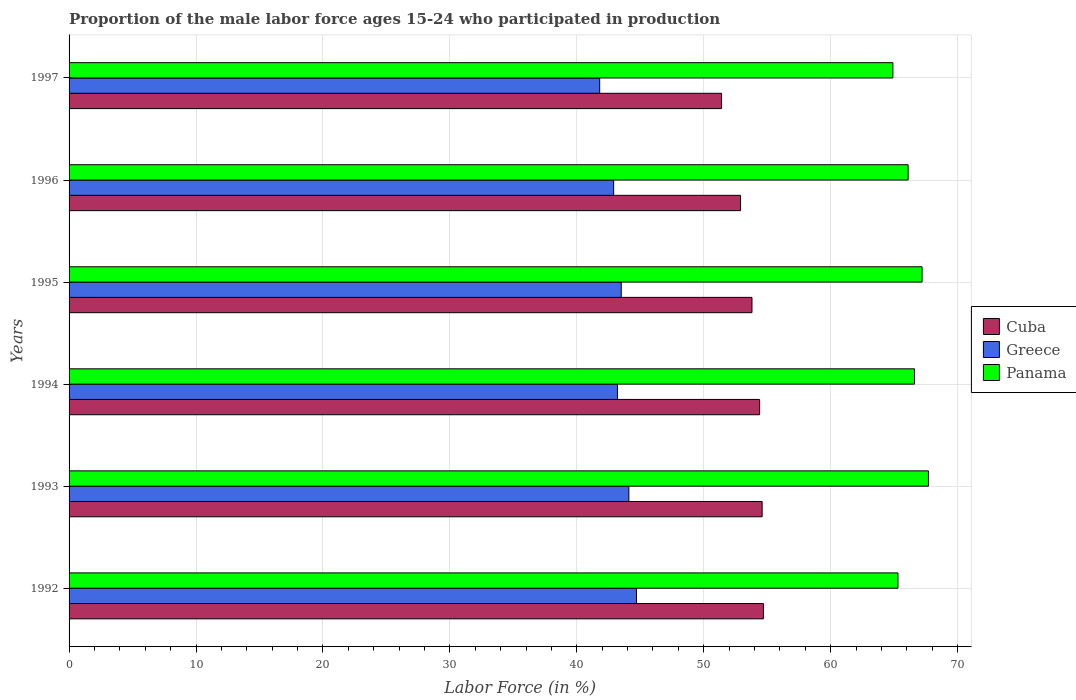What is the proportion of the male labor force who participated in production in Panama in 1996?
Keep it short and to the point. 66.1. Across all years, what is the maximum proportion of the male labor force who participated in production in Greece?
Offer a terse response. 44.7. Across all years, what is the minimum proportion of the male labor force who participated in production in Cuba?
Provide a short and direct response. 51.4. In which year was the proportion of the male labor force who participated in production in Cuba maximum?
Provide a short and direct response. 1992. In which year was the proportion of the male labor force who participated in production in Cuba minimum?
Your answer should be compact. 1997. What is the total proportion of the male labor force who participated in production in Cuba in the graph?
Keep it short and to the point. 321.8. What is the difference between the proportion of the male labor force who participated in production in Panama in 1994 and that in 1995?
Provide a short and direct response. -0.6. What is the difference between the proportion of the male labor force who participated in production in Greece in 1994 and the proportion of the male labor force who participated in production in Panama in 1996?
Keep it short and to the point. -22.9. What is the average proportion of the male labor force who participated in production in Greece per year?
Provide a succinct answer. 43.37. In the year 1994, what is the difference between the proportion of the male labor force who participated in production in Cuba and proportion of the male labor force who participated in production in Greece?
Give a very brief answer. 11.2. In how many years, is the proportion of the male labor force who participated in production in Panama greater than 58 %?
Offer a terse response. 6. What is the ratio of the proportion of the male labor force who participated in production in Panama in 1994 to that in 1997?
Your answer should be very brief. 1.03. Is the proportion of the male labor force who participated in production in Greece in 1992 less than that in 1997?
Your answer should be very brief. No. Is the difference between the proportion of the male labor force who participated in production in Cuba in 1993 and 1994 greater than the difference between the proportion of the male labor force who participated in production in Greece in 1993 and 1994?
Keep it short and to the point. No. What is the difference between the highest and the second highest proportion of the male labor force who participated in production in Cuba?
Give a very brief answer. 0.1. What is the difference between the highest and the lowest proportion of the male labor force who participated in production in Panama?
Ensure brevity in your answer.  2.8. Is the sum of the proportion of the male labor force who participated in production in Greece in 1993 and 1997 greater than the maximum proportion of the male labor force who participated in production in Cuba across all years?
Keep it short and to the point. Yes. What does the 1st bar from the top in 1994 represents?
Ensure brevity in your answer.  Panama. What does the 3rd bar from the bottom in 1993 represents?
Make the answer very short. Panama. Are all the bars in the graph horizontal?
Keep it short and to the point. Yes. Are the values on the major ticks of X-axis written in scientific E-notation?
Provide a succinct answer. No. Does the graph contain any zero values?
Offer a very short reply. No. Does the graph contain grids?
Give a very brief answer. Yes. How many legend labels are there?
Offer a very short reply. 3. How are the legend labels stacked?
Your response must be concise. Vertical. What is the title of the graph?
Offer a very short reply. Proportion of the male labor force ages 15-24 who participated in production. Does "Sao Tome and Principe" appear as one of the legend labels in the graph?
Provide a short and direct response. No. What is the label or title of the X-axis?
Ensure brevity in your answer.  Labor Force (in %). What is the label or title of the Y-axis?
Make the answer very short. Years. What is the Labor Force (in %) in Cuba in 1992?
Offer a very short reply. 54.7. What is the Labor Force (in %) of Greece in 1992?
Ensure brevity in your answer.  44.7. What is the Labor Force (in %) in Panama in 1992?
Your response must be concise. 65.3. What is the Labor Force (in %) in Cuba in 1993?
Your response must be concise. 54.6. What is the Labor Force (in %) of Greece in 1993?
Give a very brief answer. 44.1. What is the Labor Force (in %) of Panama in 1993?
Provide a short and direct response. 67.7. What is the Labor Force (in %) in Cuba in 1994?
Provide a short and direct response. 54.4. What is the Labor Force (in %) in Greece in 1994?
Offer a very short reply. 43.2. What is the Labor Force (in %) in Panama in 1994?
Provide a short and direct response. 66.6. What is the Labor Force (in %) of Cuba in 1995?
Give a very brief answer. 53.8. What is the Labor Force (in %) of Greece in 1995?
Ensure brevity in your answer.  43.5. What is the Labor Force (in %) in Panama in 1995?
Offer a terse response. 67.2. What is the Labor Force (in %) of Cuba in 1996?
Your answer should be very brief. 52.9. What is the Labor Force (in %) of Greece in 1996?
Make the answer very short. 42.9. What is the Labor Force (in %) in Panama in 1996?
Your response must be concise. 66.1. What is the Labor Force (in %) in Cuba in 1997?
Offer a very short reply. 51.4. What is the Labor Force (in %) in Greece in 1997?
Offer a very short reply. 41.8. What is the Labor Force (in %) in Panama in 1997?
Keep it short and to the point. 64.9. Across all years, what is the maximum Labor Force (in %) of Cuba?
Your answer should be compact. 54.7. Across all years, what is the maximum Labor Force (in %) of Greece?
Your answer should be compact. 44.7. Across all years, what is the maximum Labor Force (in %) in Panama?
Provide a short and direct response. 67.7. Across all years, what is the minimum Labor Force (in %) in Cuba?
Provide a short and direct response. 51.4. Across all years, what is the minimum Labor Force (in %) of Greece?
Your response must be concise. 41.8. Across all years, what is the minimum Labor Force (in %) in Panama?
Make the answer very short. 64.9. What is the total Labor Force (in %) in Cuba in the graph?
Provide a short and direct response. 321.8. What is the total Labor Force (in %) in Greece in the graph?
Your answer should be compact. 260.2. What is the total Labor Force (in %) in Panama in the graph?
Make the answer very short. 397.8. What is the difference between the Labor Force (in %) of Cuba in 1992 and that in 1993?
Ensure brevity in your answer.  0.1. What is the difference between the Labor Force (in %) of Panama in 1992 and that in 1993?
Make the answer very short. -2.4. What is the difference between the Labor Force (in %) in Cuba in 1992 and that in 1994?
Give a very brief answer. 0.3. What is the difference between the Labor Force (in %) of Greece in 1992 and that in 1994?
Offer a terse response. 1.5. What is the difference between the Labor Force (in %) in Panama in 1992 and that in 1994?
Your response must be concise. -1.3. What is the difference between the Labor Force (in %) of Greece in 1992 and that in 1995?
Keep it short and to the point. 1.2. What is the difference between the Labor Force (in %) of Greece in 1992 and that in 1996?
Your answer should be very brief. 1.8. What is the difference between the Labor Force (in %) of Panama in 1992 and that in 1996?
Your answer should be compact. -0.8. What is the difference between the Labor Force (in %) in Cuba in 1992 and that in 1997?
Your answer should be compact. 3.3. What is the difference between the Labor Force (in %) of Greece in 1992 and that in 1997?
Your response must be concise. 2.9. What is the difference between the Labor Force (in %) in Panama in 1992 and that in 1997?
Offer a very short reply. 0.4. What is the difference between the Labor Force (in %) in Cuba in 1993 and that in 1994?
Offer a very short reply. 0.2. What is the difference between the Labor Force (in %) of Greece in 1993 and that in 1995?
Provide a short and direct response. 0.6. What is the difference between the Labor Force (in %) of Panama in 1993 and that in 1995?
Keep it short and to the point. 0.5. What is the difference between the Labor Force (in %) in Greece in 1993 and that in 1996?
Ensure brevity in your answer.  1.2. What is the difference between the Labor Force (in %) of Panama in 1993 and that in 1996?
Keep it short and to the point. 1.6. What is the difference between the Labor Force (in %) in Cuba in 1993 and that in 1997?
Your answer should be very brief. 3.2. What is the difference between the Labor Force (in %) of Greece in 1993 and that in 1997?
Your answer should be compact. 2.3. What is the difference between the Labor Force (in %) in Panama in 1993 and that in 1997?
Keep it short and to the point. 2.8. What is the difference between the Labor Force (in %) of Cuba in 1994 and that in 1995?
Provide a short and direct response. 0.6. What is the difference between the Labor Force (in %) in Greece in 1994 and that in 1995?
Provide a short and direct response. -0.3. What is the difference between the Labor Force (in %) of Panama in 1994 and that in 1995?
Make the answer very short. -0.6. What is the difference between the Labor Force (in %) of Greece in 1994 and that in 1996?
Provide a short and direct response. 0.3. What is the difference between the Labor Force (in %) of Panama in 1994 and that in 1996?
Ensure brevity in your answer.  0.5. What is the difference between the Labor Force (in %) of Cuba in 1994 and that in 1997?
Your answer should be compact. 3. What is the difference between the Labor Force (in %) of Greece in 1995 and that in 1996?
Your answer should be very brief. 0.6. What is the difference between the Labor Force (in %) of Cuba in 1995 and that in 1997?
Your response must be concise. 2.4. What is the difference between the Labor Force (in %) of Greece in 1996 and that in 1997?
Offer a very short reply. 1.1. What is the difference between the Labor Force (in %) of Cuba in 1992 and the Labor Force (in %) of Greece in 1994?
Your answer should be compact. 11.5. What is the difference between the Labor Force (in %) in Greece in 1992 and the Labor Force (in %) in Panama in 1994?
Provide a short and direct response. -21.9. What is the difference between the Labor Force (in %) in Cuba in 1992 and the Labor Force (in %) in Greece in 1995?
Provide a short and direct response. 11.2. What is the difference between the Labor Force (in %) of Greece in 1992 and the Labor Force (in %) of Panama in 1995?
Provide a succinct answer. -22.5. What is the difference between the Labor Force (in %) of Cuba in 1992 and the Labor Force (in %) of Panama in 1996?
Give a very brief answer. -11.4. What is the difference between the Labor Force (in %) in Greece in 1992 and the Labor Force (in %) in Panama in 1996?
Make the answer very short. -21.4. What is the difference between the Labor Force (in %) in Cuba in 1992 and the Labor Force (in %) in Panama in 1997?
Provide a succinct answer. -10.2. What is the difference between the Labor Force (in %) of Greece in 1992 and the Labor Force (in %) of Panama in 1997?
Offer a terse response. -20.2. What is the difference between the Labor Force (in %) of Cuba in 1993 and the Labor Force (in %) of Greece in 1994?
Ensure brevity in your answer.  11.4. What is the difference between the Labor Force (in %) of Greece in 1993 and the Labor Force (in %) of Panama in 1994?
Give a very brief answer. -22.5. What is the difference between the Labor Force (in %) in Cuba in 1993 and the Labor Force (in %) in Panama in 1995?
Make the answer very short. -12.6. What is the difference between the Labor Force (in %) of Greece in 1993 and the Labor Force (in %) of Panama in 1995?
Offer a very short reply. -23.1. What is the difference between the Labor Force (in %) of Cuba in 1993 and the Labor Force (in %) of Panama in 1996?
Provide a succinct answer. -11.5. What is the difference between the Labor Force (in %) in Greece in 1993 and the Labor Force (in %) in Panama in 1996?
Make the answer very short. -22. What is the difference between the Labor Force (in %) in Greece in 1993 and the Labor Force (in %) in Panama in 1997?
Your answer should be compact. -20.8. What is the difference between the Labor Force (in %) of Cuba in 1994 and the Labor Force (in %) of Panama in 1995?
Your answer should be compact. -12.8. What is the difference between the Labor Force (in %) in Cuba in 1994 and the Labor Force (in %) in Greece in 1996?
Provide a short and direct response. 11.5. What is the difference between the Labor Force (in %) in Cuba in 1994 and the Labor Force (in %) in Panama in 1996?
Your answer should be very brief. -11.7. What is the difference between the Labor Force (in %) in Greece in 1994 and the Labor Force (in %) in Panama in 1996?
Offer a terse response. -22.9. What is the difference between the Labor Force (in %) in Cuba in 1994 and the Labor Force (in %) in Greece in 1997?
Ensure brevity in your answer.  12.6. What is the difference between the Labor Force (in %) of Greece in 1994 and the Labor Force (in %) of Panama in 1997?
Offer a very short reply. -21.7. What is the difference between the Labor Force (in %) in Cuba in 1995 and the Labor Force (in %) in Greece in 1996?
Your answer should be compact. 10.9. What is the difference between the Labor Force (in %) of Greece in 1995 and the Labor Force (in %) of Panama in 1996?
Give a very brief answer. -22.6. What is the difference between the Labor Force (in %) of Cuba in 1995 and the Labor Force (in %) of Greece in 1997?
Keep it short and to the point. 12. What is the difference between the Labor Force (in %) of Greece in 1995 and the Labor Force (in %) of Panama in 1997?
Your response must be concise. -21.4. What is the average Labor Force (in %) of Cuba per year?
Keep it short and to the point. 53.63. What is the average Labor Force (in %) in Greece per year?
Your response must be concise. 43.37. What is the average Labor Force (in %) in Panama per year?
Your answer should be compact. 66.3. In the year 1992, what is the difference between the Labor Force (in %) of Greece and Labor Force (in %) of Panama?
Provide a short and direct response. -20.6. In the year 1993, what is the difference between the Labor Force (in %) in Cuba and Labor Force (in %) in Greece?
Provide a short and direct response. 10.5. In the year 1993, what is the difference between the Labor Force (in %) of Greece and Labor Force (in %) of Panama?
Your answer should be very brief. -23.6. In the year 1994, what is the difference between the Labor Force (in %) in Cuba and Labor Force (in %) in Greece?
Your response must be concise. 11.2. In the year 1994, what is the difference between the Labor Force (in %) in Greece and Labor Force (in %) in Panama?
Provide a short and direct response. -23.4. In the year 1995, what is the difference between the Labor Force (in %) of Cuba and Labor Force (in %) of Greece?
Offer a very short reply. 10.3. In the year 1995, what is the difference between the Labor Force (in %) of Greece and Labor Force (in %) of Panama?
Offer a very short reply. -23.7. In the year 1996, what is the difference between the Labor Force (in %) in Cuba and Labor Force (in %) in Greece?
Ensure brevity in your answer.  10. In the year 1996, what is the difference between the Labor Force (in %) in Cuba and Labor Force (in %) in Panama?
Give a very brief answer. -13.2. In the year 1996, what is the difference between the Labor Force (in %) in Greece and Labor Force (in %) in Panama?
Offer a very short reply. -23.2. In the year 1997, what is the difference between the Labor Force (in %) in Cuba and Labor Force (in %) in Greece?
Offer a terse response. 9.6. In the year 1997, what is the difference between the Labor Force (in %) in Cuba and Labor Force (in %) in Panama?
Provide a succinct answer. -13.5. In the year 1997, what is the difference between the Labor Force (in %) in Greece and Labor Force (in %) in Panama?
Keep it short and to the point. -23.1. What is the ratio of the Labor Force (in %) in Greece in 1992 to that in 1993?
Offer a very short reply. 1.01. What is the ratio of the Labor Force (in %) in Panama in 1992 to that in 1993?
Offer a very short reply. 0.96. What is the ratio of the Labor Force (in %) of Greece in 1992 to that in 1994?
Offer a terse response. 1.03. What is the ratio of the Labor Force (in %) in Panama in 1992 to that in 1994?
Offer a very short reply. 0.98. What is the ratio of the Labor Force (in %) of Cuba in 1992 to that in 1995?
Your answer should be compact. 1.02. What is the ratio of the Labor Force (in %) of Greece in 1992 to that in 1995?
Offer a terse response. 1.03. What is the ratio of the Labor Force (in %) in Panama in 1992 to that in 1995?
Your answer should be compact. 0.97. What is the ratio of the Labor Force (in %) of Cuba in 1992 to that in 1996?
Your answer should be very brief. 1.03. What is the ratio of the Labor Force (in %) of Greece in 1992 to that in 1996?
Give a very brief answer. 1.04. What is the ratio of the Labor Force (in %) in Panama in 1992 to that in 1996?
Provide a short and direct response. 0.99. What is the ratio of the Labor Force (in %) in Cuba in 1992 to that in 1997?
Ensure brevity in your answer.  1.06. What is the ratio of the Labor Force (in %) in Greece in 1992 to that in 1997?
Offer a very short reply. 1.07. What is the ratio of the Labor Force (in %) in Panama in 1992 to that in 1997?
Give a very brief answer. 1.01. What is the ratio of the Labor Force (in %) in Greece in 1993 to that in 1994?
Your answer should be very brief. 1.02. What is the ratio of the Labor Force (in %) in Panama in 1993 to that in 1994?
Your response must be concise. 1.02. What is the ratio of the Labor Force (in %) in Cuba in 1993 to that in 1995?
Make the answer very short. 1.01. What is the ratio of the Labor Force (in %) of Greece in 1993 to that in 1995?
Offer a terse response. 1.01. What is the ratio of the Labor Force (in %) in Panama in 1993 to that in 1995?
Provide a short and direct response. 1.01. What is the ratio of the Labor Force (in %) of Cuba in 1993 to that in 1996?
Ensure brevity in your answer.  1.03. What is the ratio of the Labor Force (in %) in Greece in 1993 to that in 1996?
Keep it short and to the point. 1.03. What is the ratio of the Labor Force (in %) in Panama in 1993 to that in 1996?
Provide a succinct answer. 1.02. What is the ratio of the Labor Force (in %) in Cuba in 1993 to that in 1997?
Offer a very short reply. 1.06. What is the ratio of the Labor Force (in %) in Greece in 1993 to that in 1997?
Give a very brief answer. 1.05. What is the ratio of the Labor Force (in %) of Panama in 1993 to that in 1997?
Your response must be concise. 1.04. What is the ratio of the Labor Force (in %) in Cuba in 1994 to that in 1995?
Ensure brevity in your answer.  1.01. What is the ratio of the Labor Force (in %) of Cuba in 1994 to that in 1996?
Your answer should be compact. 1.03. What is the ratio of the Labor Force (in %) in Panama in 1994 to that in 1996?
Your answer should be very brief. 1.01. What is the ratio of the Labor Force (in %) in Cuba in 1994 to that in 1997?
Provide a short and direct response. 1.06. What is the ratio of the Labor Force (in %) of Greece in 1994 to that in 1997?
Your answer should be very brief. 1.03. What is the ratio of the Labor Force (in %) in Panama in 1994 to that in 1997?
Offer a terse response. 1.03. What is the ratio of the Labor Force (in %) of Panama in 1995 to that in 1996?
Ensure brevity in your answer.  1.02. What is the ratio of the Labor Force (in %) of Cuba in 1995 to that in 1997?
Offer a very short reply. 1.05. What is the ratio of the Labor Force (in %) of Greece in 1995 to that in 1997?
Offer a terse response. 1.04. What is the ratio of the Labor Force (in %) in Panama in 1995 to that in 1997?
Your answer should be compact. 1.04. What is the ratio of the Labor Force (in %) in Cuba in 1996 to that in 1997?
Make the answer very short. 1.03. What is the ratio of the Labor Force (in %) in Greece in 1996 to that in 1997?
Ensure brevity in your answer.  1.03. What is the ratio of the Labor Force (in %) in Panama in 1996 to that in 1997?
Give a very brief answer. 1.02. What is the difference between the highest and the second highest Labor Force (in %) in Cuba?
Your response must be concise. 0.1. What is the difference between the highest and the second highest Labor Force (in %) in Panama?
Make the answer very short. 0.5. What is the difference between the highest and the lowest Labor Force (in %) of Cuba?
Keep it short and to the point. 3.3. What is the difference between the highest and the lowest Labor Force (in %) in Panama?
Your answer should be very brief. 2.8. 